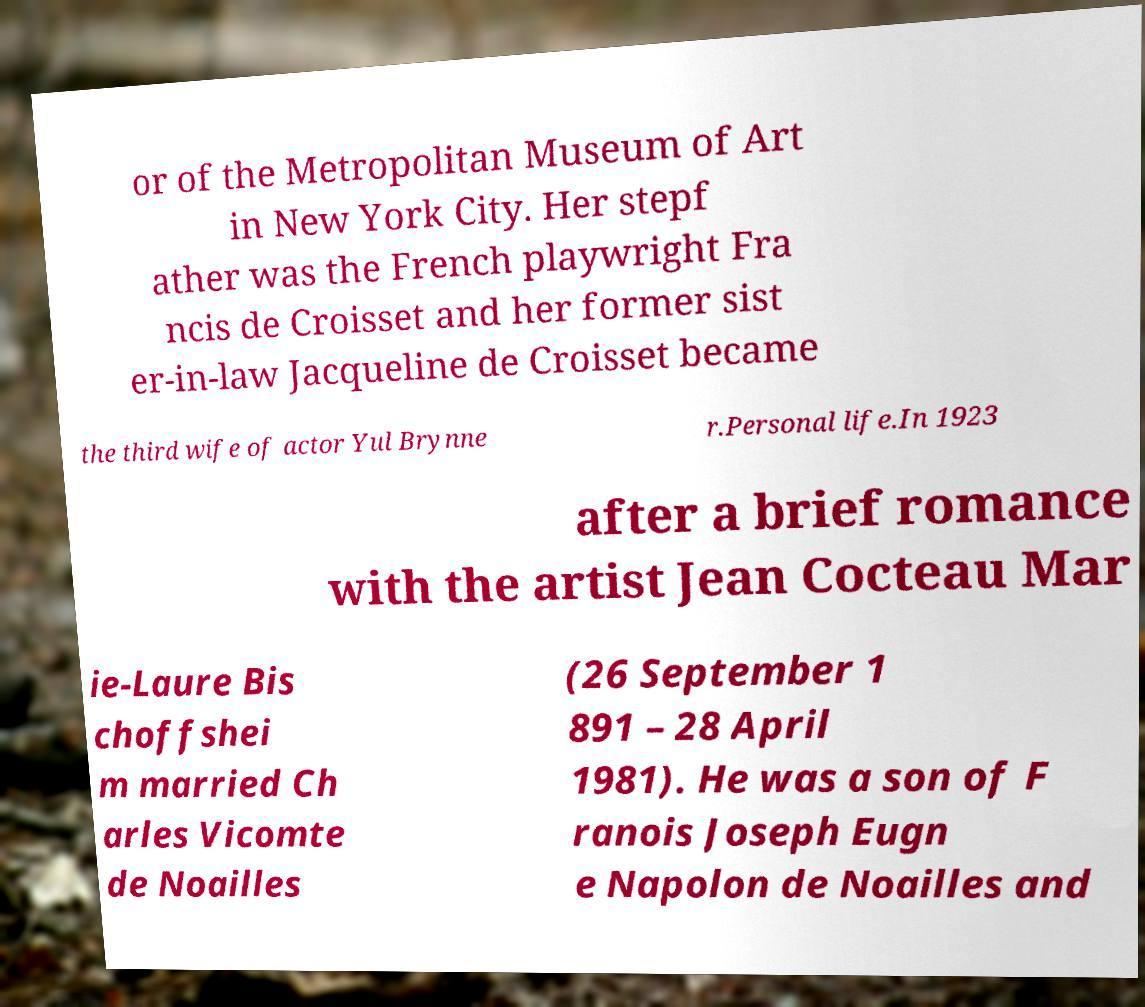Can you accurately transcribe the text from the provided image for me? or of the Metropolitan Museum of Art in New York City. Her stepf ather was the French playwright Fra ncis de Croisset and her former sist er-in-law Jacqueline de Croisset became the third wife of actor Yul Brynne r.Personal life.In 1923 after a brief romance with the artist Jean Cocteau Mar ie-Laure Bis choffshei m married Ch arles Vicomte de Noailles (26 September 1 891 – 28 April 1981). He was a son of F ranois Joseph Eugn e Napolon de Noailles and 